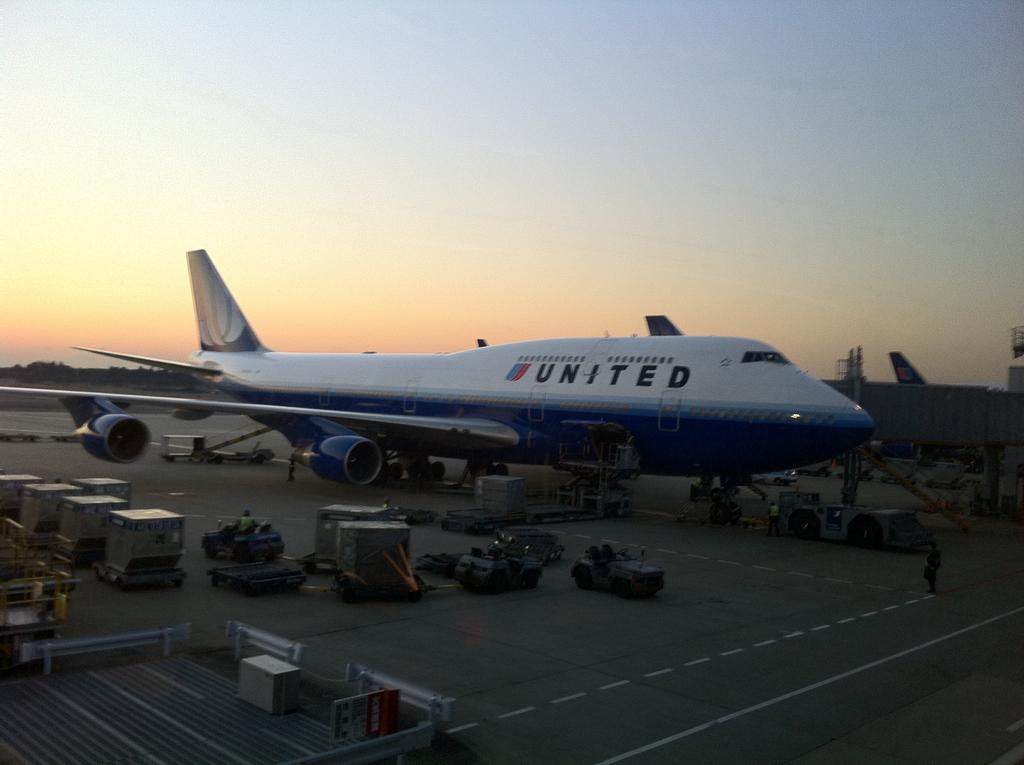Provide a one-sentence caption for the provided image. United plane that is on land is surrounded around people. 